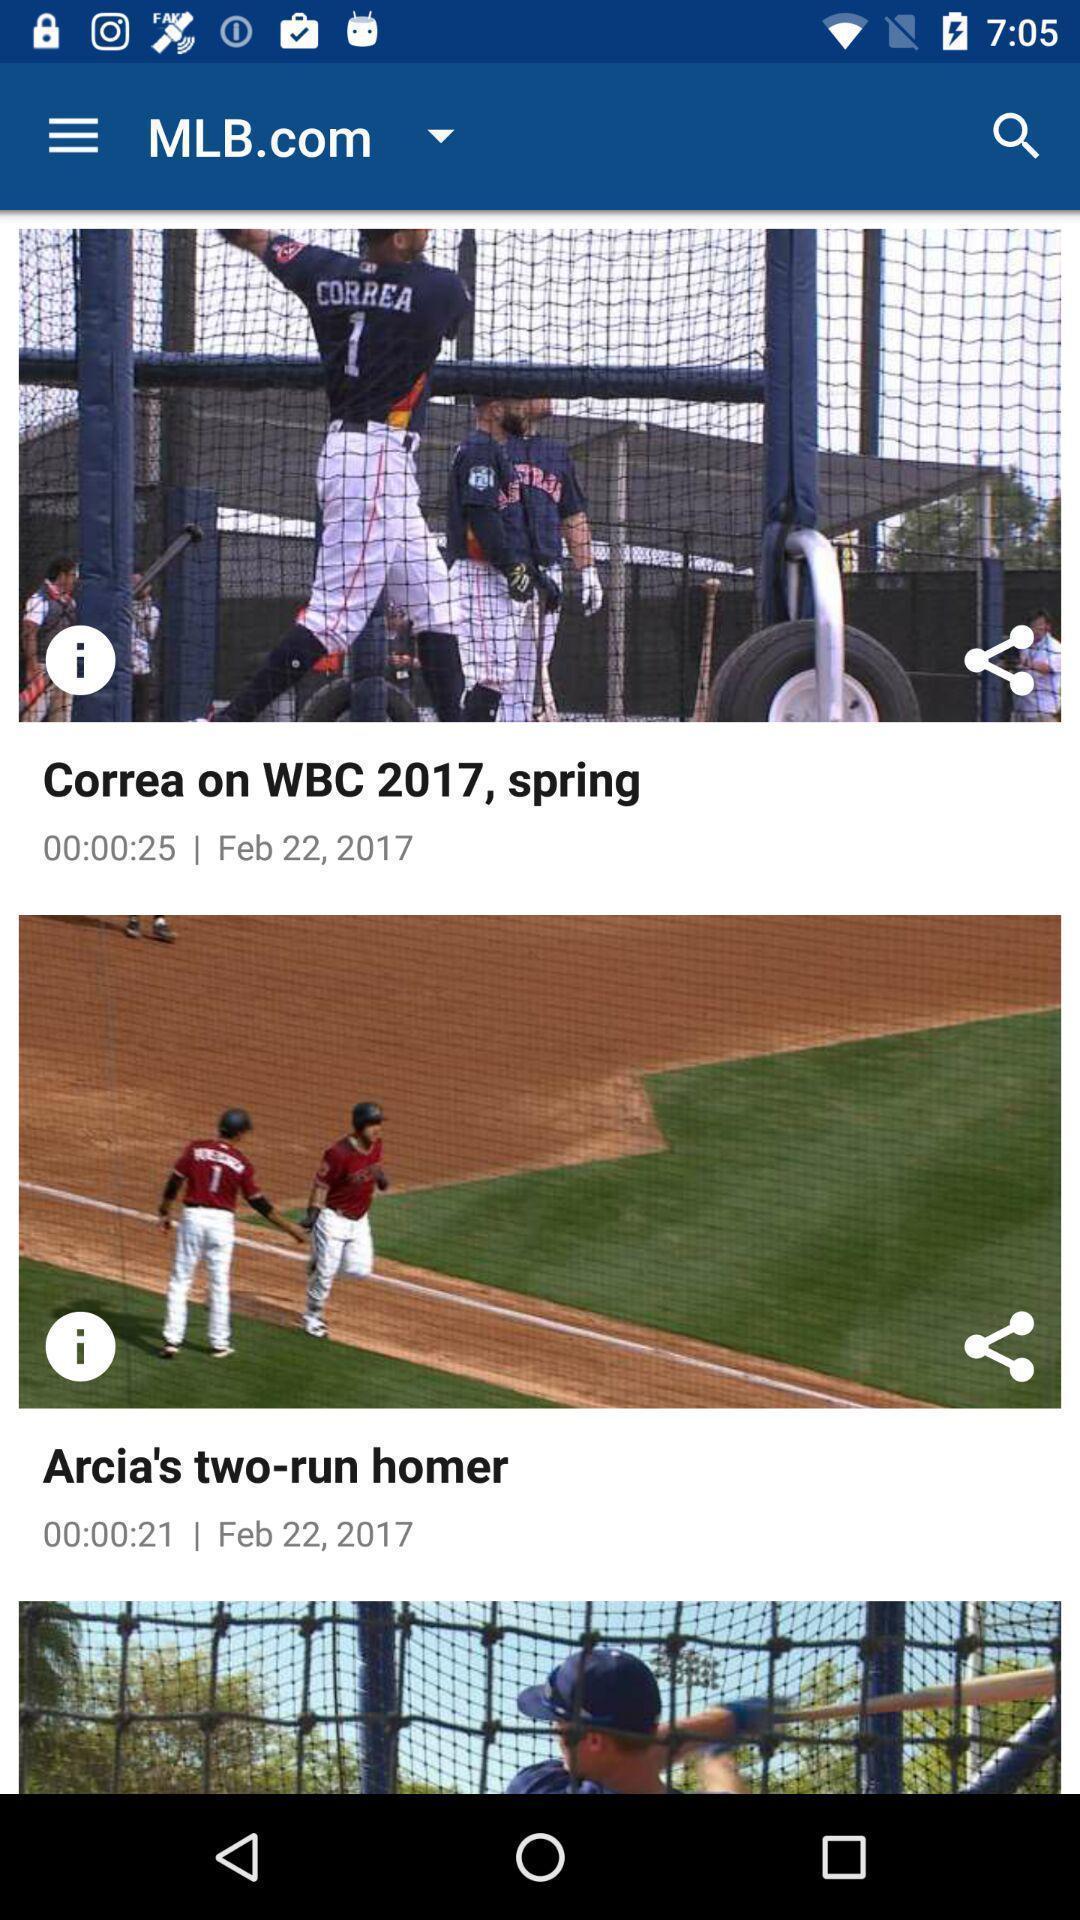Summarize the information in this screenshot. Page showing content in a sports app. 